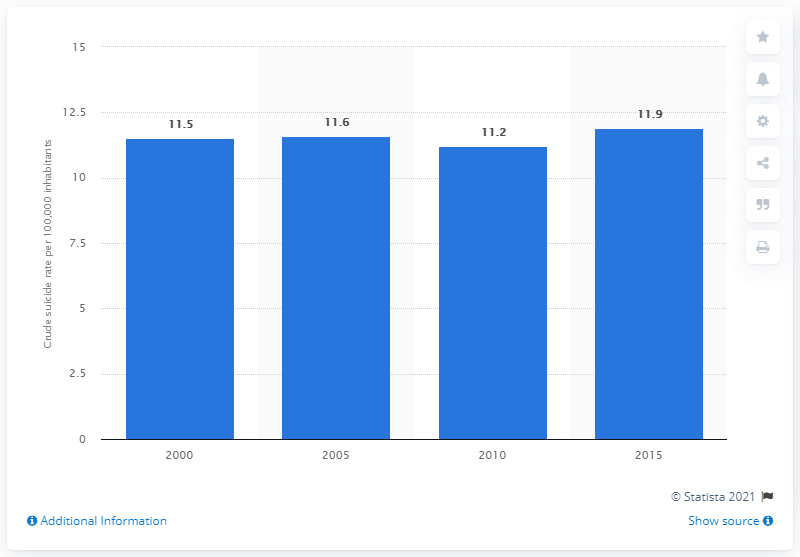Mention a couple of crucial points in this snapshot. In 2015, the crude suicide rate in Cambodia was 11.9 per 100,000 population, according to data from the World Health Organization. 